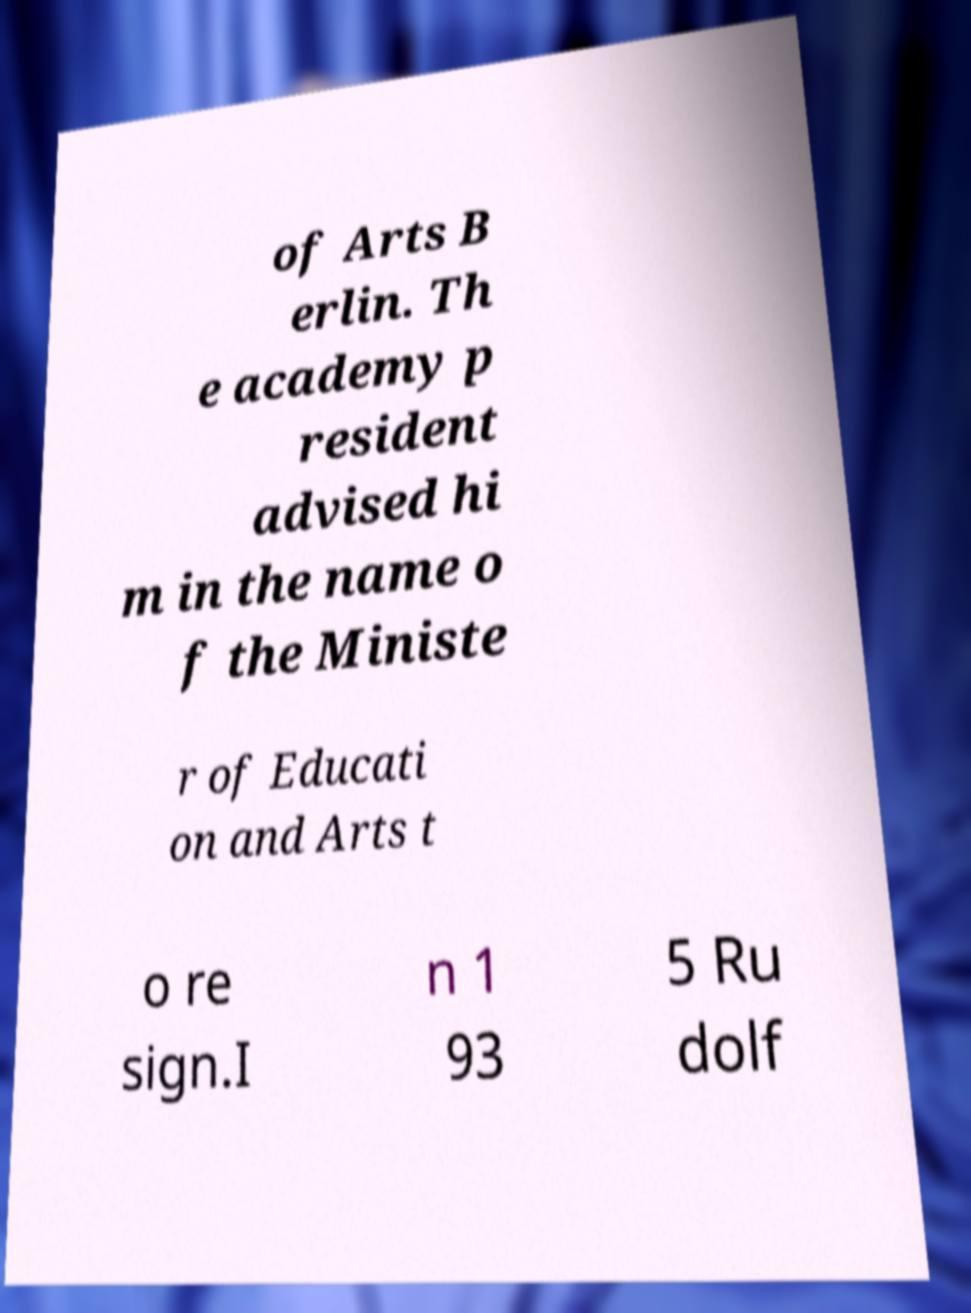Could you assist in decoding the text presented in this image and type it out clearly? of Arts B erlin. Th e academy p resident advised hi m in the name o f the Ministe r of Educati on and Arts t o re sign.I n 1 93 5 Ru dolf 